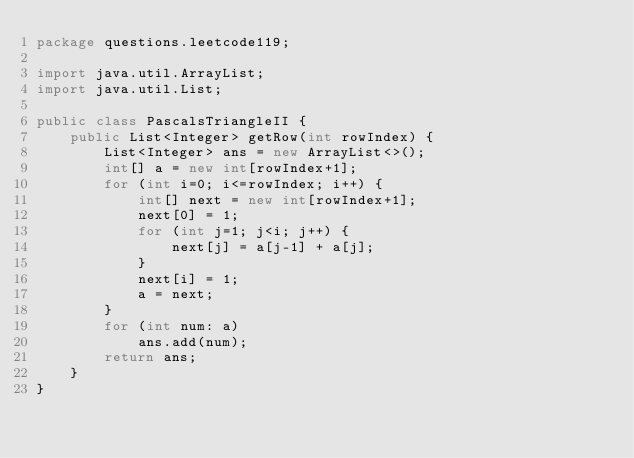<code> <loc_0><loc_0><loc_500><loc_500><_Java_>package questions.leetcode119;

import java.util.ArrayList;
import java.util.List;

public class PascalsTriangleII {
    public List<Integer> getRow(int rowIndex) {
        List<Integer> ans = new ArrayList<>();
        int[] a = new int[rowIndex+1];
        for (int i=0; i<=rowIndex; i++) {
            int[] next = new int[rowIndex+1];
            next[0] = 1;
            for (int j=1; j<i; j++) {
                next[j] = a[j-1] + a[j];
            }
            next[i] = 1;
            a = next;
        }
        for (int num: a)
            ans.add(num);
        return ans;
    }
}
</code> 